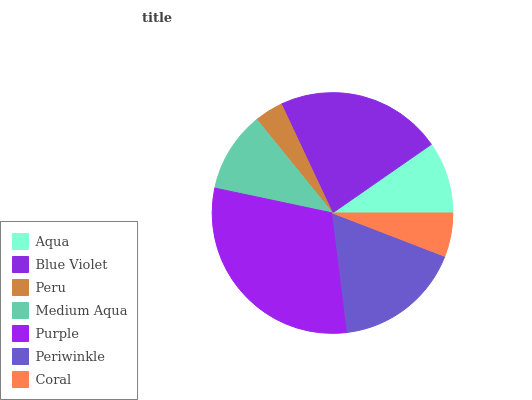Is Peru the minimum?
Answer yes or no. Yes. Is Purple the maximum?
Answer yes or no. Yes. Is Blue Violet the minimum?
Answer yes or no. No. Is Blue Violet the maximum?
Answer yes or no. No. Is Blue Violet greater than Aqua?
Answer yes or no. Yes. Is Aqua less than Blue Violet?
Answer yes or no. Yes. Is Aqua greater than Blue Violet?
Answer yes or no. No. Is Blue Violet less than Aqua?
Answer yes or no. No. Is Medium Aqua the high median?
Answer yes or no. Yes. Is Medium Aqua the low median?
Answer yes or no. Yes. Is Peru the high median?
Answer yes or no. No. Is Purple the low median?
Answer yes or no. No. 